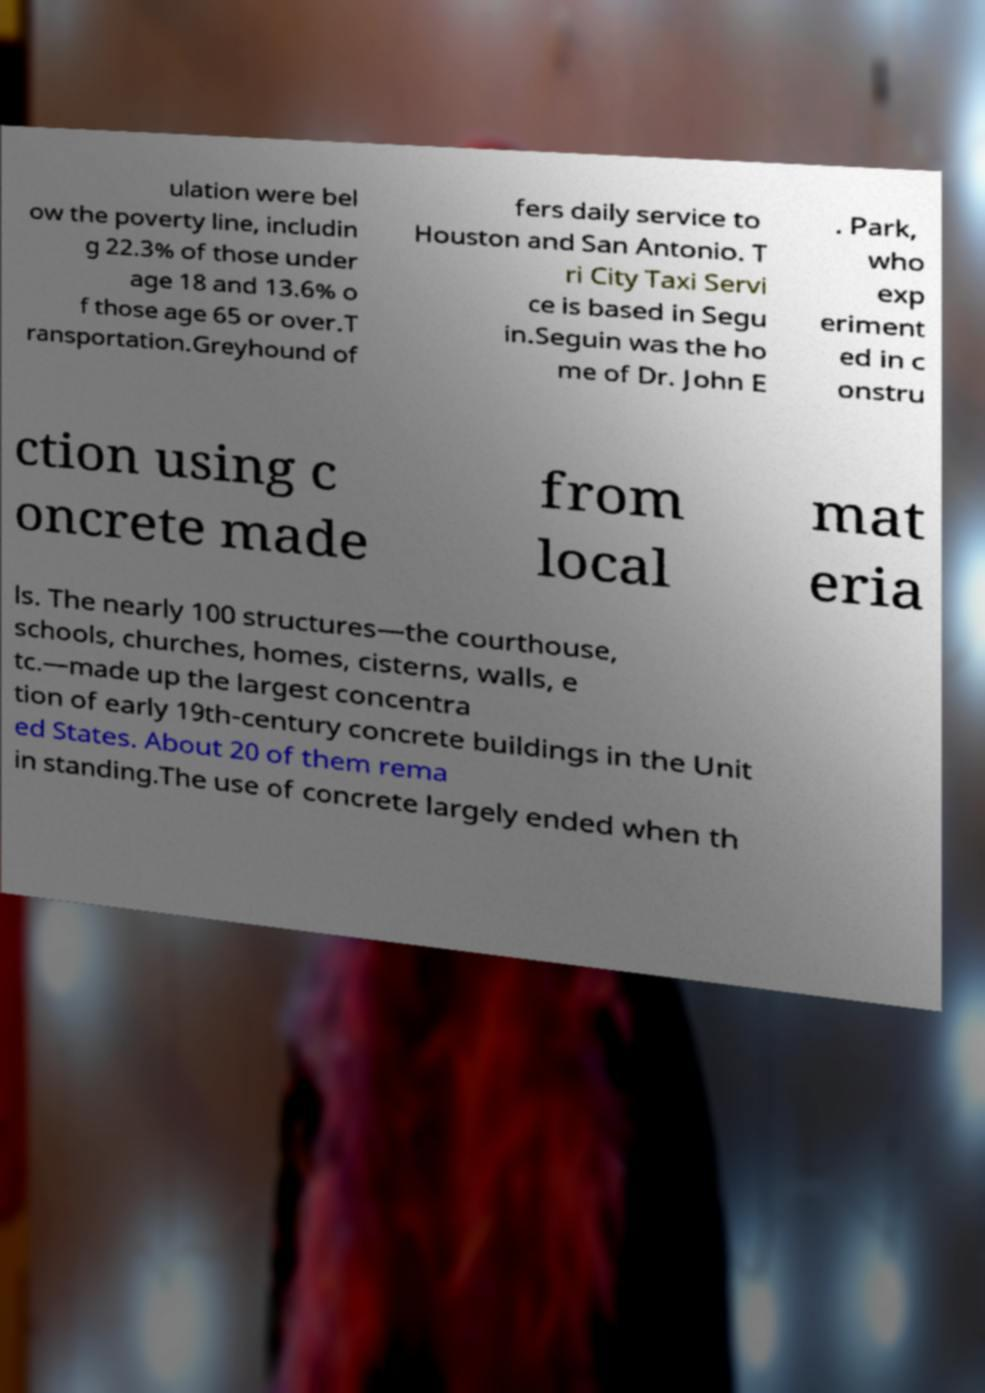Please identify and transcribe the text found in this image. ulation were bel ow the poverty line, includin g 22.3% of those under age 18 and 13.6% o f those age 65 or over.T ransportation.Greyhound of fers daily service to Houston and San Antonio. T ri City Taxi Servi ce is based in Segu in.Seguin was the ho me of Dr. John E . Park, who exp eriment ed in c onstru ction using c oncrete made from local mat eria ls. The nearly 100 structures—the courthouse, schools, churches, homes, cisterns, walls, e tc.—made up the largest concentra tion of early 19th-century concrete buildings in the Unit ed States. About 20 of them rema in standing.The use of concrete largely ended when th 